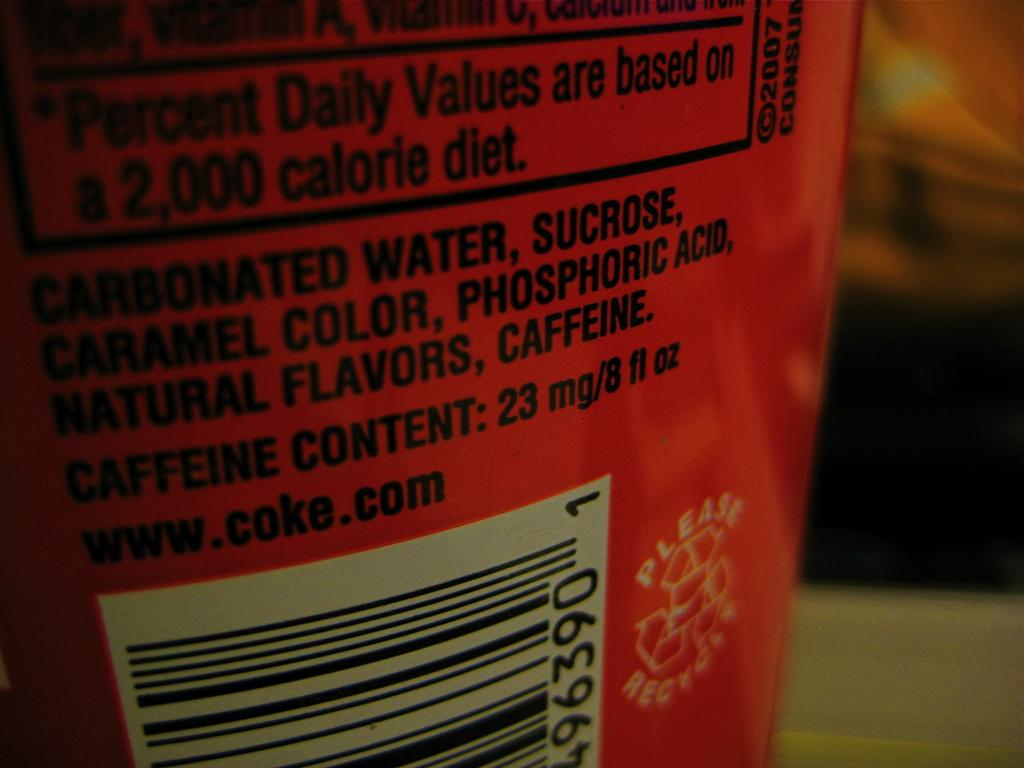What is the main object in the center of the image? There is a tin in the center of the image. What type of note is attached to the tin with a string in the image? There is no note or string attached to the tin in the image. 